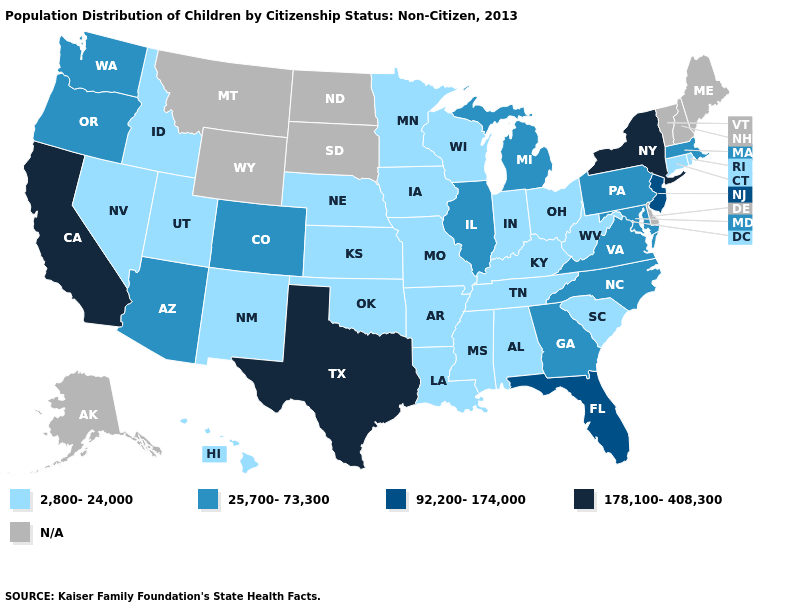Among the states that border Ohio , does Pennsylvania have the highest value?
Short answer required. Yes. Which states have the highest value in the USA?
Give a very brief answer. California, New York, Texas. Does Michigan have the highest value in the MidWest?
Quick response, please. Yes. What is the value of Delaware?
Quick response, please. N/A. Which states hav the highest value in the Northeast?
Concise answer only. New York. Among the states that border New Mexico , which have the highest value?
Short answer required. Texas. Among the states that border Connecticut , does Rhode Island have the lowest value?
Give a very brief answer. Yes. What is the value of Florida?
Be succinct. 92,200-174,000. Name the states that have a value in the range N/A?
Write a very short answer. Alaska, Delaware, Maine, Montana, New Hampshire, North Dakota, South Dakota, Vermont, Wyoming. Which states have the highest value in the USA?
Quick response, please. California, New York, Texas. Does the first symbol in the legend represent the smallest category?
Keep it brief. Yes. What is the value of South Dakota?
Write a very short answer. N/A. What is the highest value in states that border Mississippi?
Answer briefly. 2,800-24,000. 